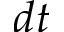Convert formula to latex. <formula><loc_0><loc_0><loc_500><loc_500>d t</formula> 